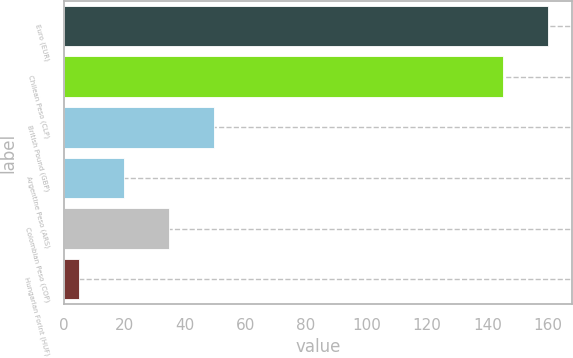<chart> <loc_0><loc_0><loc_500><loc_500><bar_chart><fcel>Euro (EUR)<fcel>Chilean Peso (CLP)<fcel>British Pound (GBP)<fcel>Argentine Peso (ARS)<fcel>Colombian Peso (COP)<fcel>Hungarian Forint (HUF)<nl><fcel>159.9<fcel>145<fcel>49.7<fcel>19.9<fcel>34.8<fcel>5<nl></chart> 